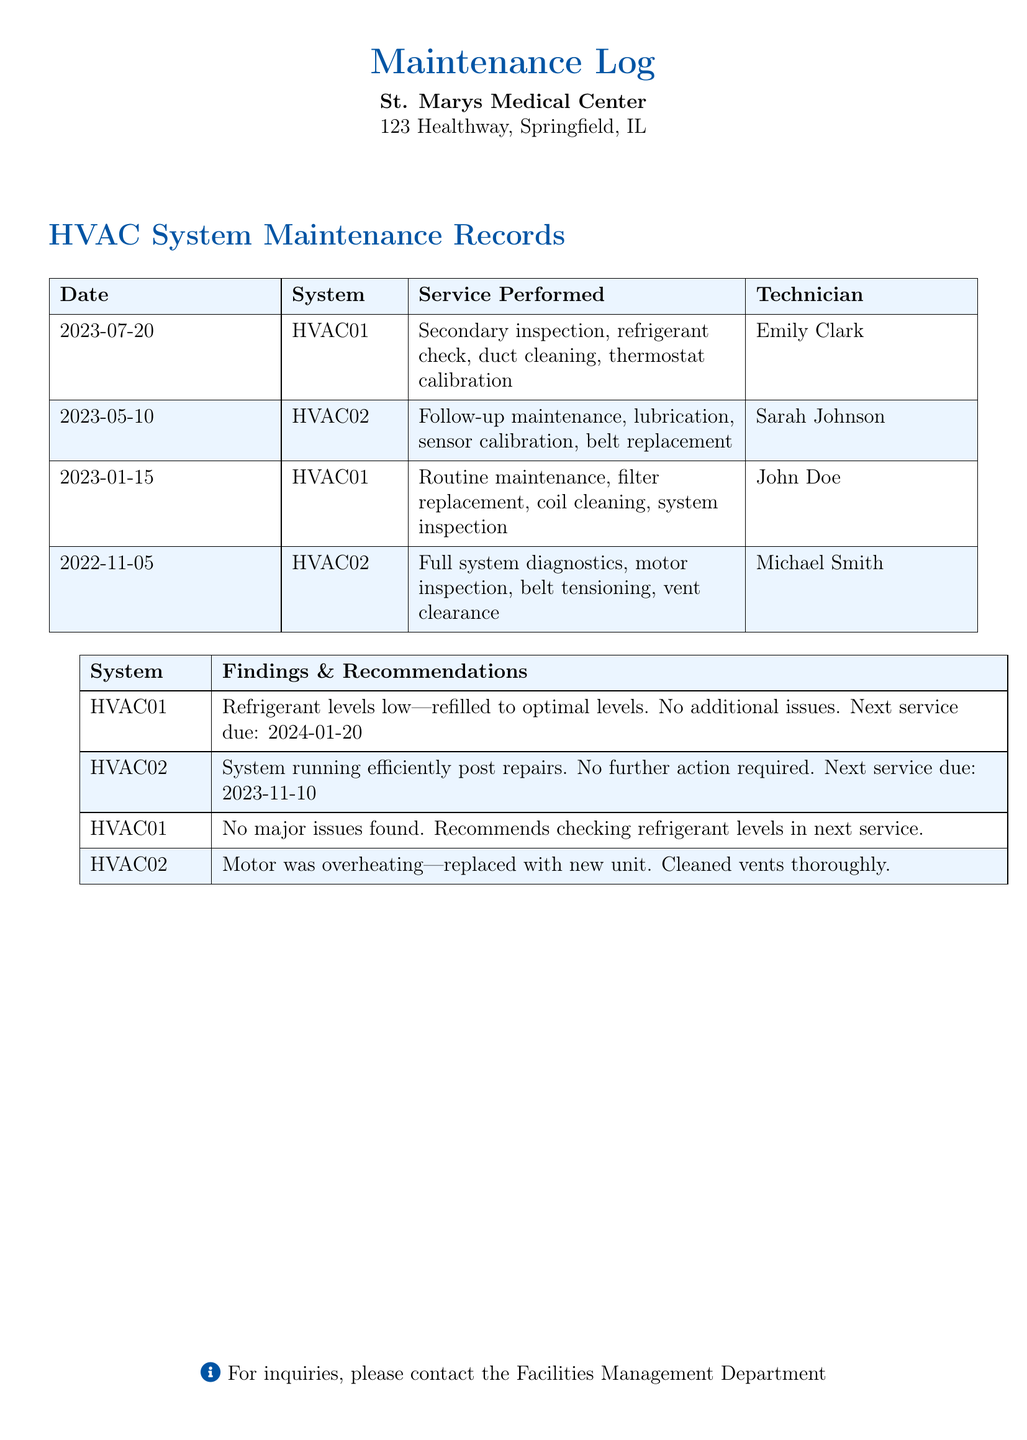What is the date of the latest maintenance recorded? The latest maintenance recorded is on July 20, 2023.
Answer: July 20, 2023 Who performed the service on HVAC02 on May 10, 2023? According to the log, Sarah Johnson performed the service on HVAC02.
Answer: Sarah Johnson What service was performed on HVAC01 on January 15, 2023? The service performed on HVAC01 included routine maintenance, filter replacement, coil cleaning, and system inspection.
Answer: Routine maintenance, filter replacement, coil cleaning, system inspection When is the next service due for HVAC02? The next service due for HVAC02 is November 10, 2023.
Answer: November 10, 2023 Which technician worked on the HVAC02 unit most recently? The technician who worked on HVAC02 most recently is Sarah Johnson.
Answer: Sarah Johnson What was the finding for HVAC01 regarding refrigerant levels? The finding states that the refrigerant levels were low and refilled to optimal levels.
Answer: Refrigerant levels low—refilled to optimal levels How many maintenance records are documented in total? There are four maintenance records documented in total in the log.
Answer: Four What action was taken regarding the motor in HVAC02? The motor in HVAC02 was replaced with a new unit.
Answer: Replaced with new unit 